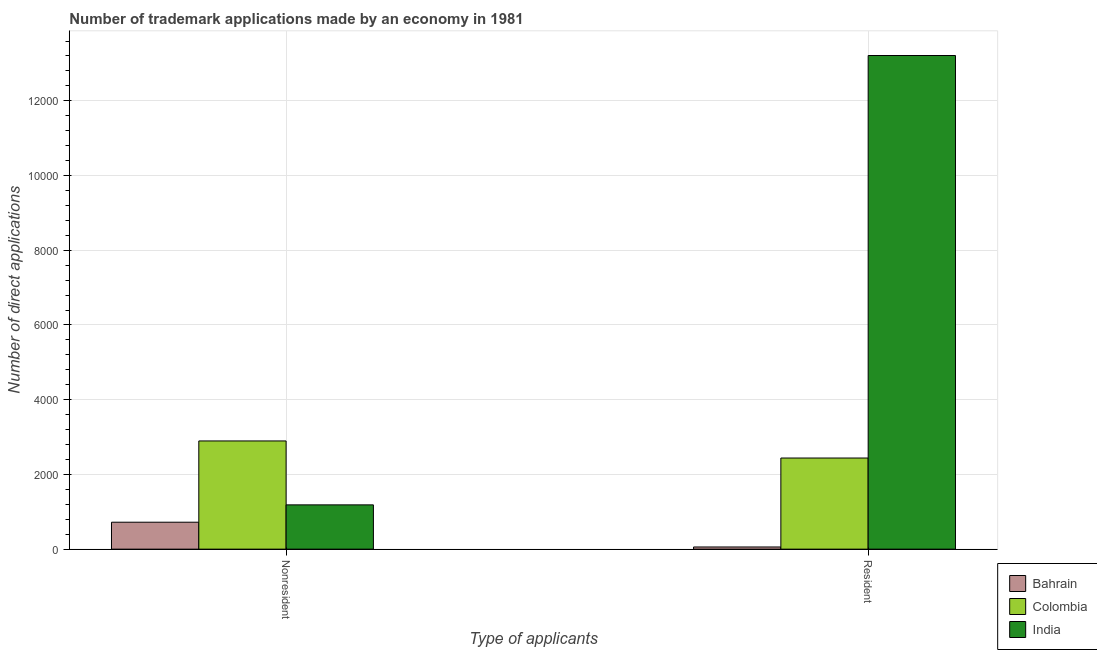How many bars are there on the 2nd tick from the right?
Your answer should be compact. 3. What is the label of the 1st group of bars from the left?
Your answer should be very brief. Nonresident. What is the number of trademark applications made by residents in India?
Your response must be concise. 1.32e+04. Across all countries, what is the maximum number of trademark applications made by non residents?
Your answer should be compact. 2896. Across all countries, what is the minimum number of trademark applications made by residents?
Offer a very short reply. 58. In which country was the number of trademark applications made by residents maximum?
Your answer should be compact. India. In which country was the number of trademark applications made by non residents minimum?
Your response must be concise. Bahrain. What is the total number of trademark applications made by residents in the graph?
Offer a terse response. 1.57e+04. What is the difference between the number of trademark applications made by non residents in Bahrain and that in India?
Provide a short and direct response. -464. What is the difference between the number of trademark applications made by residents in Bahrain and the number of trademark applications made by non residents in Colombia?
Your response must be concise. -2838. What is the average number of trademark applications made by non residents per country?
Your answer should be very brief. 1600.67. What is the difference between the number of trademark applications made by residents and number of trademark applications made by non residents in Colombia?
Give a very brief answer. -457. In how many countries, is the number of trademark applications made by non residents greater than 1200 ?
Make the answer very short. 1. What is the ratio of the number of trademark applications made by non residents in India to that in Colombia?
Your response must be concise. 0.41. Is the number of trademark applications made by residents in Colombia less than that in India?
Provide a short and direct response. Yes. What does the 1st bar from the left in Nonresident represents?
Your answer should be compact. Bahrain. What does the 3rd bar from the right in Resident represents?
Your response must be concise. Bahrain. Are all the bars in the graph horizontal?
Ensure brevity in your answer.  No. Are the values on the major ticks of Y-axis written in scientific E-notation?
Offer a very short reply. No. Where does the legend appear in the graph?
Your answer should be very brief. Bottom right. How many legend labels are there?
Provide a short and direct response. 3. What is the title of the graph?
Provide a succinct answer. Number of trademark applications made by an economy in 1981. What is the label or title of the X-axis?
Provide a succinct answer. Type of applicants. What is the label or title of the Y-axis?
Provide a short and direct response. Number of direct applications. What is the Number of direct applications of Bahrain in Nonresident?
Offer a terse response. 721. What is the Number of direct applications in Colombia in Nonresident?
Your answer should be very brief. 2896. What is the Number of direct applications in India in Nonresident?
Your response must be concise. 1185. What is the Number of direct applications of Colombia in Resident?
Your response must be concise. 2439. What is the Number of direct applications of India in Resident?
Your answer should be compact. 1.32e+04. Across all Type of applicants, what is the maximum Number of direct applications of Bahrain?
Offer a very short reply. 721. Across all Type of applicants, what is the maximum Number of direct applications in Colombia?
Your answer should be very brief. 2896. Across all Type of applicants, what is the maximum Number of direct applications of India?
Your response must be concise. 1.32e+04. Across all Type of applicants, what is the minimum Number of direct applications in Colombia?
Provide a succinct answer. 2439. Across all Type of applicants, what is the minimum Number of direct applications of India?
Give a very brief answer. 1185. What is the total Number of direct applications in Bahrain in the graph?
Your answer should be very brief. 779. What is the total Number of direct applications in Colombia in the graph?
Your answer should be compact. 5335. What is the total Number of direct applications of India in the graph?
Provide a succinct answer. 1.44e+04. What is the difference between the Number of direct applications of Bahrain in Nonresident and that in Resident?
Make the answer very short. 663. What is the difference between the Number of direct applications of Colombia in Nonresident and that in Resident?
Your answer should be very brief. 457. What is the difference between the Number of direct applications of India in Nonresident and that in Resident?
Your answer should be compact. -1.20e+04. What is the difference between the Number of direct applications in Bahrain in Nonresident and the Number of direct applications in Colombia in Resident?
Your response must be concise. -1718. What is the difference between the Number of direct applications in Bahrain in Nonresident and the Number of direct applications in India in Resident?
Make the answer very short. -1.25e+04. What is the difference between the Number of direct applications in Colombia in Nonresident and the Number of direct applications in India in Resident?
Give a very brief answer. -1.03e+04. What is the average Number of direct applications in Bahrain per Type of applicants?
Offer a very short reply. 389.5. What is the average Number of direct applications of Colombia per Type of applicants?
Your answer should be compact. 2667.5. What is the average Number of direct applications in India per Type of applicants?
Keep it short and to the point. 7198.5. What is the difference between the Number of direct applications in Bahrain and Number of direct applications in Colombia in Nonresident?
Offer a terse response. -2175. What is the difference between the Number of direct applications of Bahrain and Number of direct applications of India in Nonresident?
Keep it short and to the point. -464. What is the difference between the Number of direct applications in Colombia and Number of direct applications in India in Nonresident?
Your response must be concise. 1711. What is the difference between the Number of direct applications in Bahrain and Number of direct applications in Colombia in Resident?
Your response must be concise. -2381. What is the difference between the Number of direct applications in Bahrain and Number of direct applications in India in Resident?
Offer a very short reply. -1.32e+04. What is the difference between the Number of direct applications of Colombia and Number of direct applications of India in Resident?
Offer a terse response. -1.08e+04. What is the ratio of the Number of direct applications in Bahrain in Nonresident to that in Resident?
Your answer should be very brief. 12.43. What is the ratio of the Number of direct applications of Colombia in Nonresident to that in Resident?
Your response must be concise. 1.19. What is the ratio of the Number of direct applications of India in Nonresident to that in Resident?
Keep it short and to the point. 0.09. What is the difference between the highest and the second highest Number of direct applications of Bahrain?
Offer a very short reply. 663. What is the difference between the highest and the second highest Number of direct applications in Colombia?
Provide a succinct answer. 457. What is the difference between the highest and the second highest Number of direct applications of India?
Provide a succinct answer. 1.20e+04. What is the difference between the highest and the lowest Number of direct applications of Bahrain?
Make the answer very short. 663. What is the difference between the highest and the lowest Number of direct applications in Colombia?
Offer a terse response. 457. What is the difference between the highest and the lowest Number of direct applications in India?
Make the answer very short. 1.20e+04. 